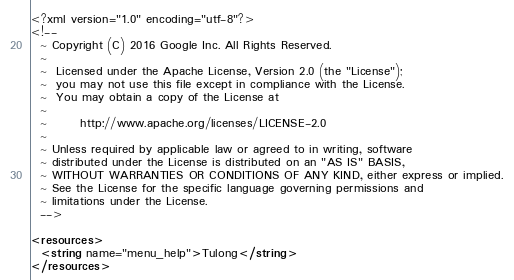<code> <loc_0><loc_0><loc_500><loc_500><_XML_><?xml version="1.0" encoding="utf-8"?>
<!--
  ~ Copyright (C) 2016 Google Inc. All Rights Reserved.
  ~
  ~  Licensed under the Apache License, Version 2.0 (the "License");
  ~  you may not use this file except in compliance with the License.
  ~  You may obtain a copy of the License at
  ~
  ~       http://www.apache.org/licenses/LICENSE-2.0
  ~
  ~ Unless required by applicable law or agreed to in writing, software
  ~ distributed under the License is distributed on an "AS IS" BASIS,
  ~ WITHOUT WARRANTIES OR CONDITIONS OF ANY KIND, either express or implied.
  ~ See the License for the specific language governing permissions and
  ~ limitations under the License.
  -->

<resources>
  <string name="menu_help">Tulong</string>
</resources>
</code> 